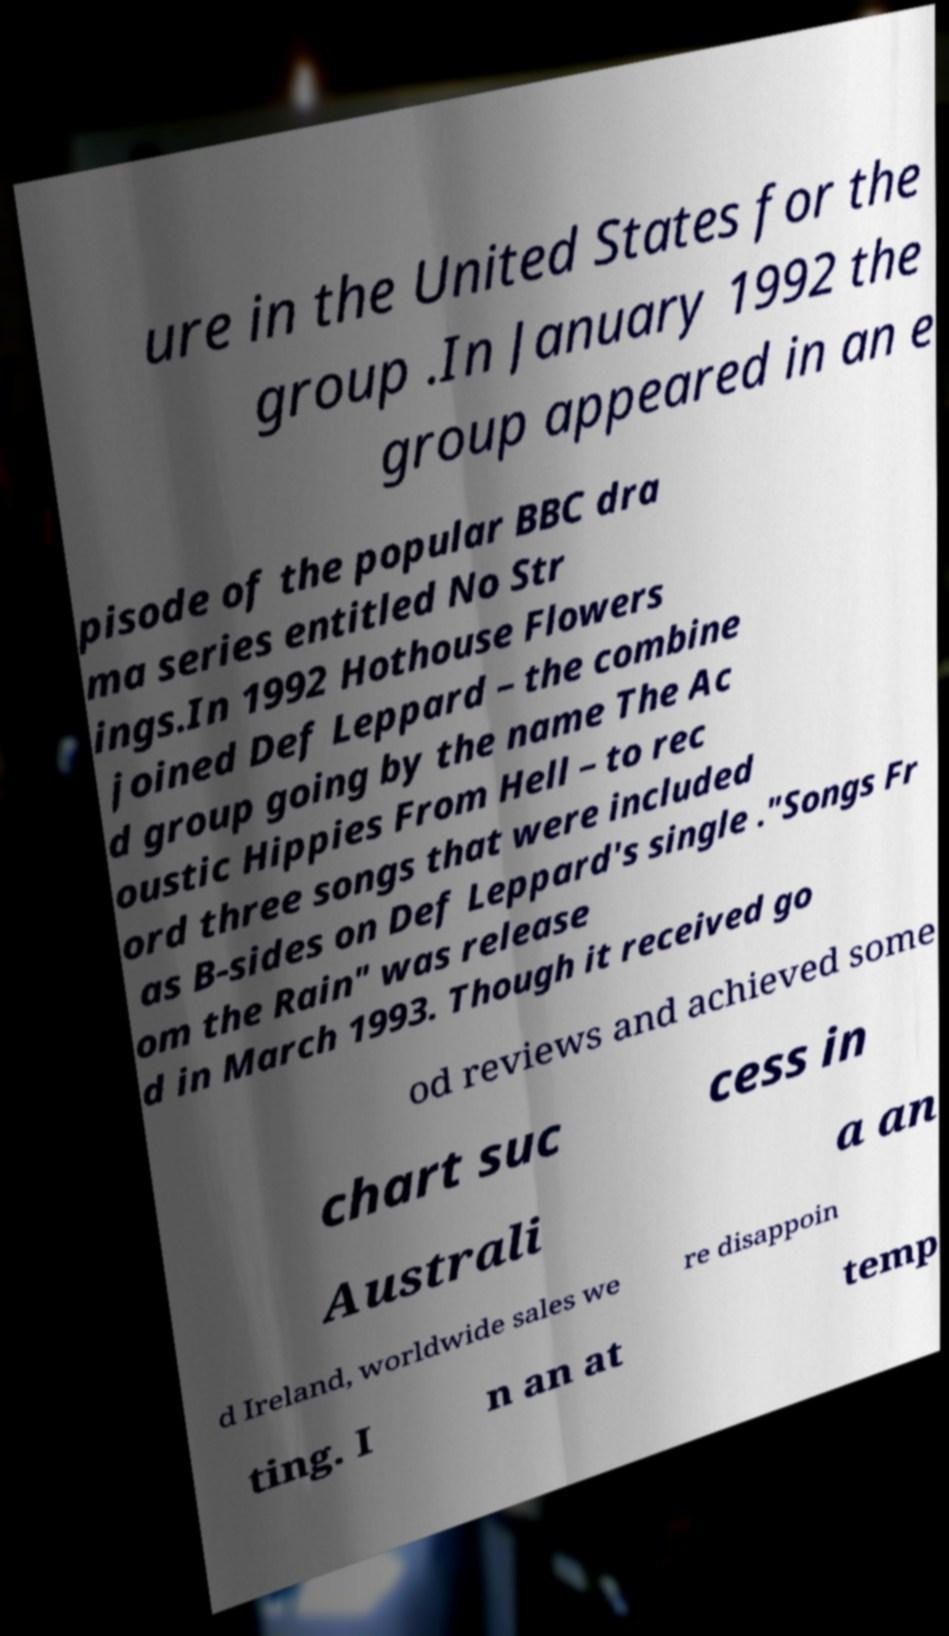Please identify and transcribe the text found in this image. ure in the United States for the group .In January 1992 the group appeared in an e pisode of the popular BBC dra ma series entitled No Str ings.In 1992 Hothouse Flowers joined Def Leppard – the combine d group going by the name The Ac oustic Hippies From Hell – to rec ord three songs that were included as B-sides on Def Leppard's single ."Songs Fr om the Rain" was release d in March 1993. Though it received go od reviews and achieved some chart suc cess in Australi a an d Ireland, worldwide sales we re disappoin ting. I n an at temp 